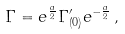Convert formula to latex. <formula><loc_0><loc_0><loc_500><loc_500>\Gamma = e ^ { \frac { a } { 2 } } \Gamma _ { ( 0 ) } ^ { \prime } e ^ { - { \frac { a } { 2 } } } \, ,</formula> 